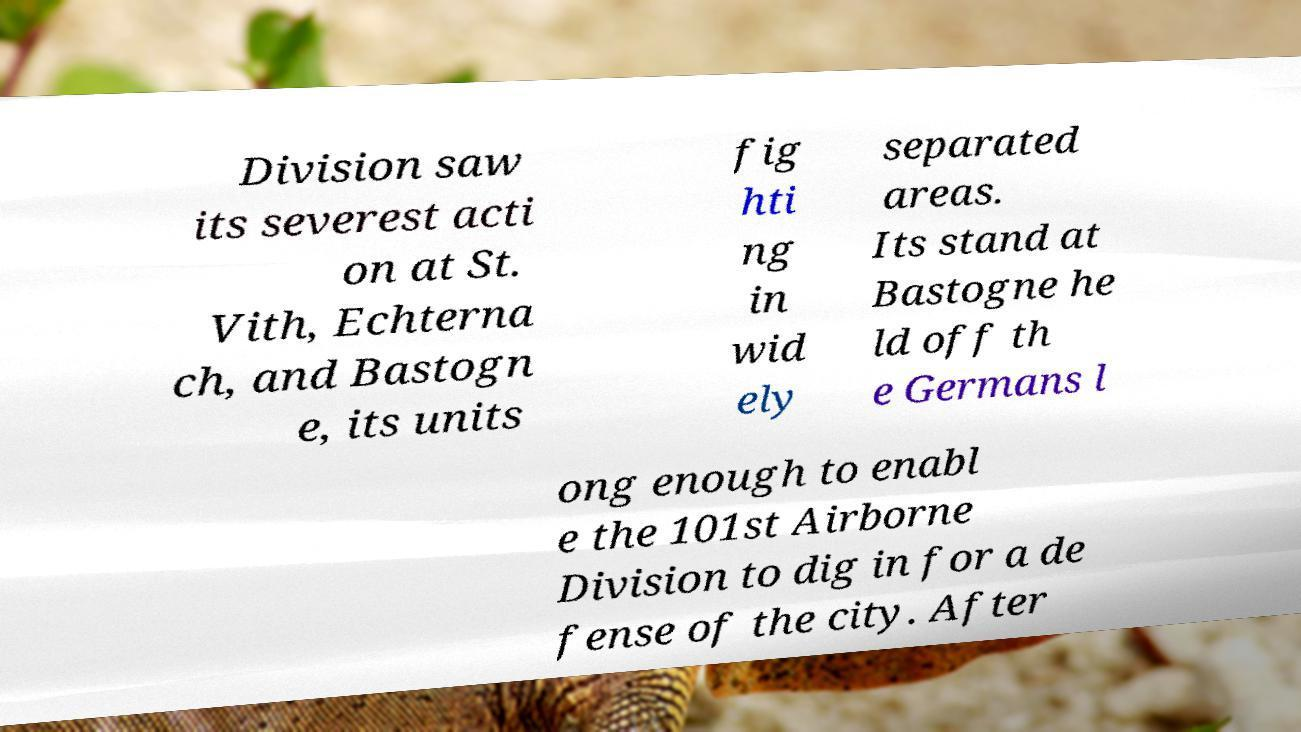I need the written content from this picture converted into text. Can you do that? Division saw its severest acti on at St. Vith, Echterna ch, and Bastogn e, its units fig hti ng in wid ely separated areas. Its stand at Bastogne he ld off th e Germans l ong enough to enabl e the 101st Airborne Division to dig in for a de fense of the city. After 